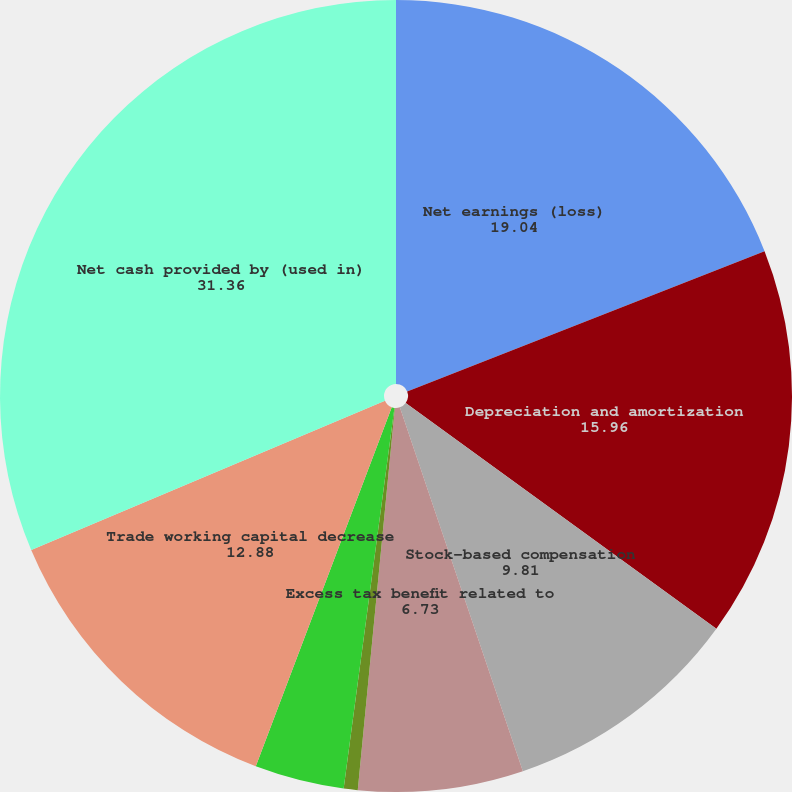Convert chart to OTSL. <chart><loc_0><loc_0><loc_500><loc_500><pie_chart><fcel>Net earnings (loss)<fcel>Depreciation and amortization<fcel>Stock-based compensation<fcel>Excess tax benefit related to<fcel>Deferred income taxes<fcel>Retiree benefit funding less<fcel>Trade working capital decrease<fcel>Net cash provided by (used in)<nl><fcel>19.04%<fcel>15.96%<fcel>9.81%<fcel>6.73%<fcel>0.57%<fcel>3.65%<fcel>12.88%<fcel>31.36%<nl></chart> 